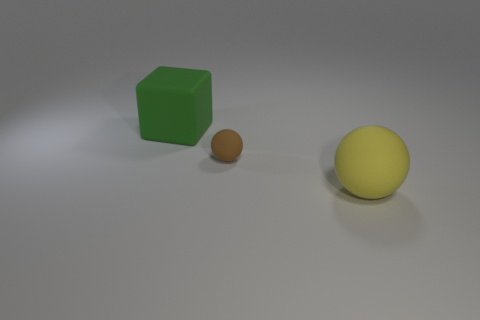There is a green cube behind the large rubber thing to the right of the large green rubber thing; how big is it?
Offer a very short reply. Large. There is a large thing behind the big yellow sphere; is it the same color as the ball that is in front of the brown matte object?
Provide a succinct answer. No. How many things are on the right side of the rubber thing to the left of the ball behind the yellow rubber sphere?
Offer a very short reply. 2. What number of spheres are on the right side of the brown thing and behind the big sphere?
Your answer should be compact. 0. Is the number of large green objects in front of the green cube the same as the number of large yellow rubber spheres that are behind the tiny matte ball?
Give a very brief answer. Yes. What is the color of the big rubber thing that is left of the big yellow ball?
Offer a terse response. Green. Are there fewer large green matte objects to the left of the green matte object than green things that are left of the large yellow thing?
Provide a succinct answer. Yes. Are there the same number of tiny brown rubber objects on the right side of the yellow thing and red metal blocks?
Offer a very short reply. Yes. How many objects are either large yellow matte objects or objects that are behind the yellow matte ball?
Your answer should be compact. 3. Is there a tiny thing that has the same material as the big green cube?
Keep it short and to the point. Yes. 